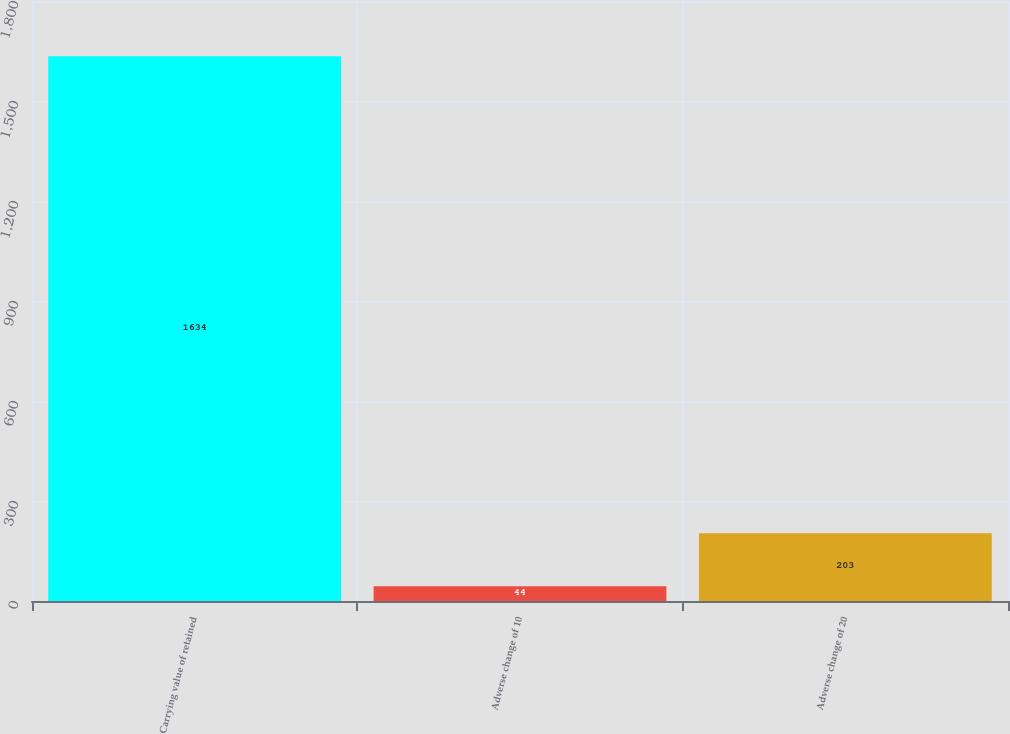<chart> <loc_0><loc_0><loc_500><loc_500><bar_chart><fcel>Carrying value of retained<fcel>Adverse change of 10<fcel>Adverse change of 20<nl><fcel>1634<fcel>44<fcel>203<nl></chart> 